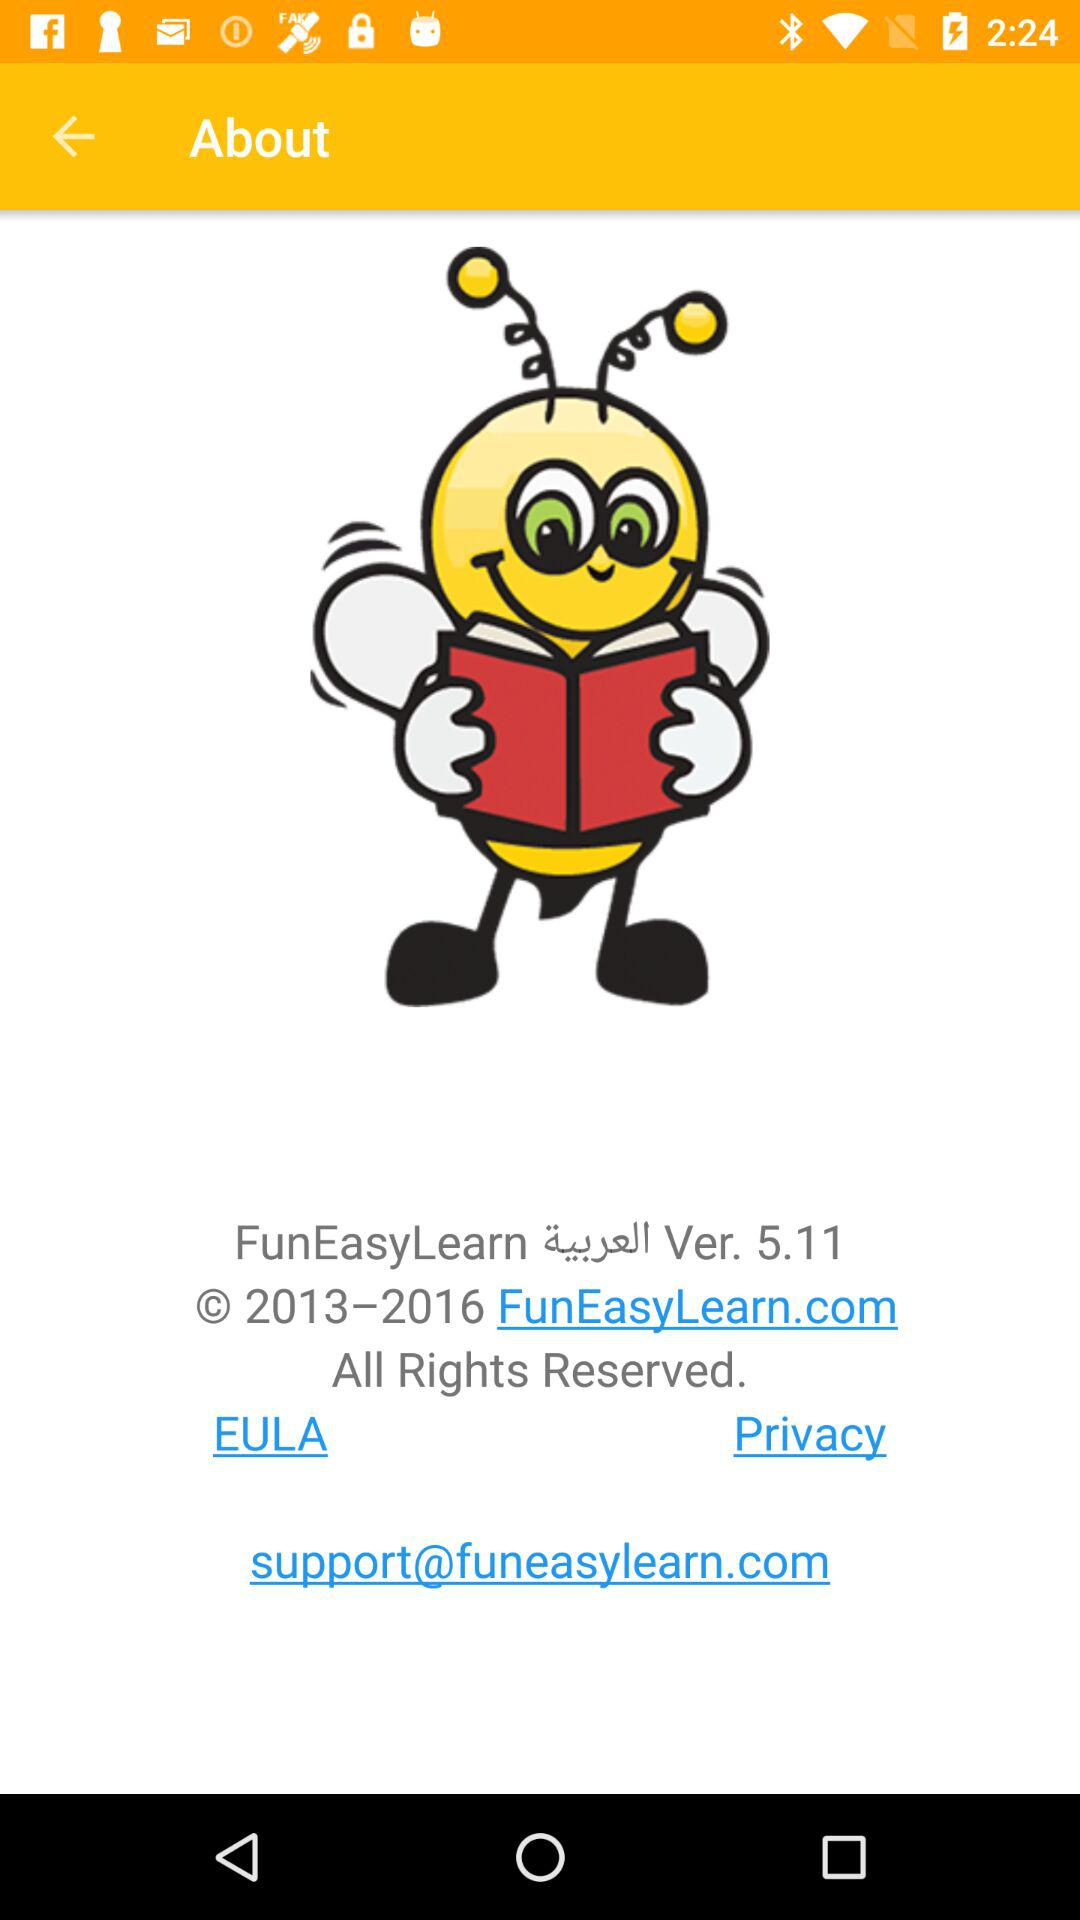What is the official website? The official website is FunEasyLearn.com. 